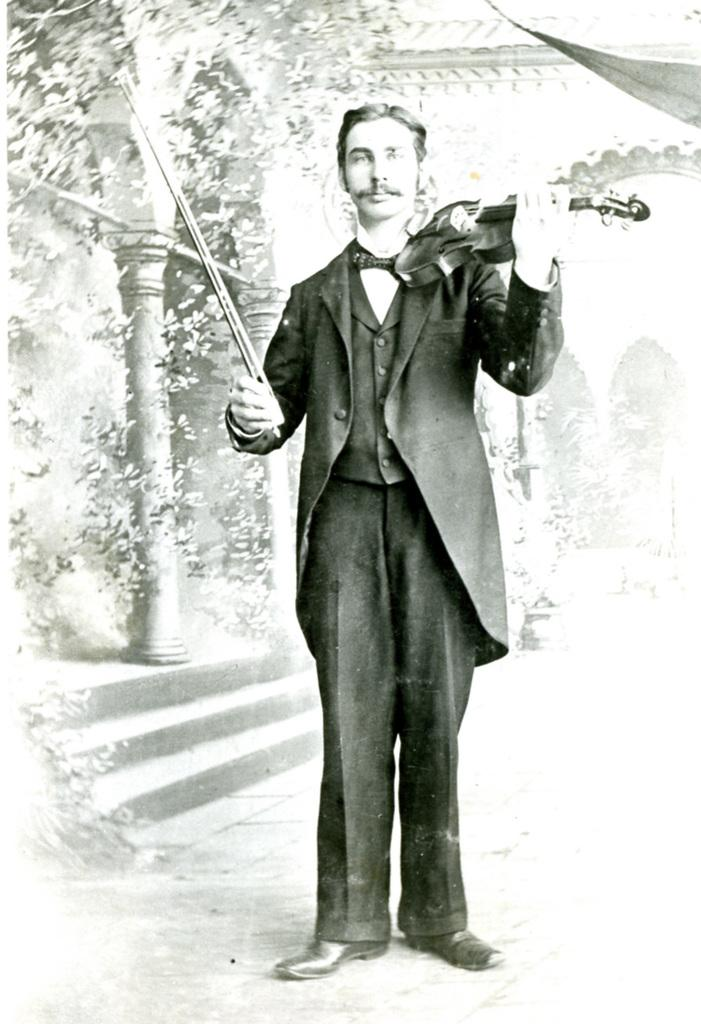What is the person in the image holding? The person is holding a violin and a stick. What might the person be doing with the violin and stick? The person might be playing the violin using the stick as a bow. What can be seen in the background of the image? There are pillars, stairs, and plants in the background of the image. What type of treatment is the person receiving for their violin playing in the image? There is no indication in the image that the person is receiving any treatment for their violin playing. How many wrens can be seen in the image? There are no wrens present in the image. 